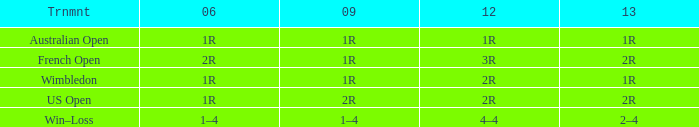What is the Tournament when the 2013 is 1r? Australian Open, Wimbledon. 